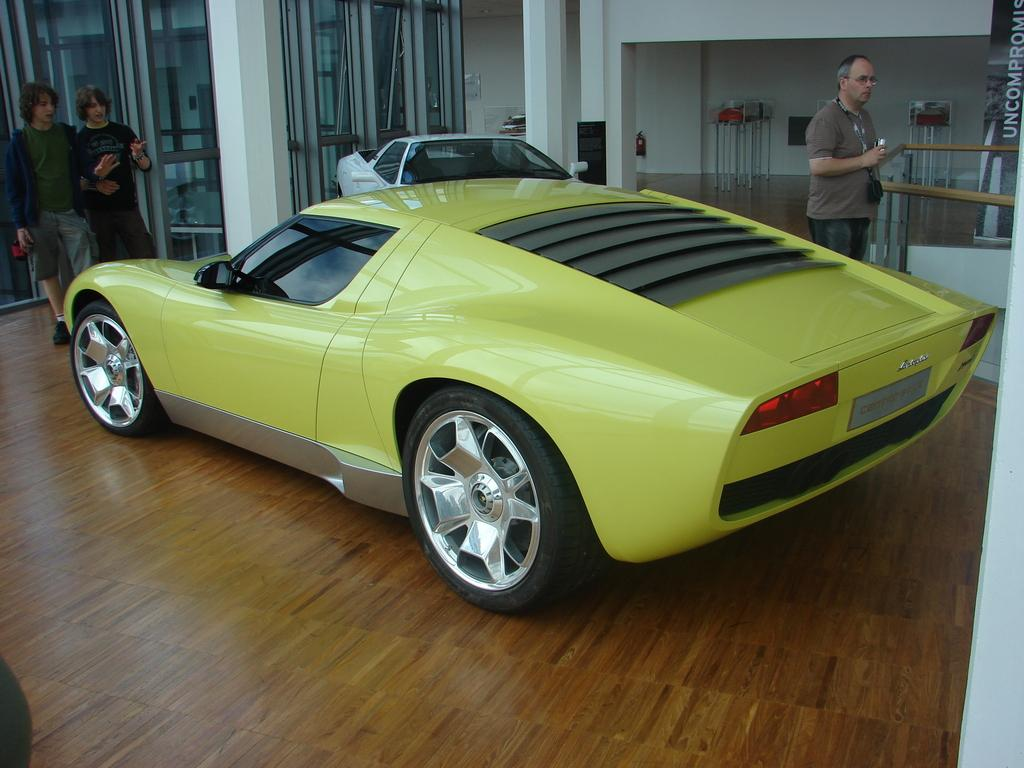How many cars are visible in the image? There are two cars in the image. How many people are standing in the image? There are three people standing in the image. What can be seen in the background of the image? In the background of the image, there are pillars, walls, a poster, and some unspecified objects. What type of bells can be heard ringing in the image? There are no bells present in the image, and therefore no sounds can be heard. 